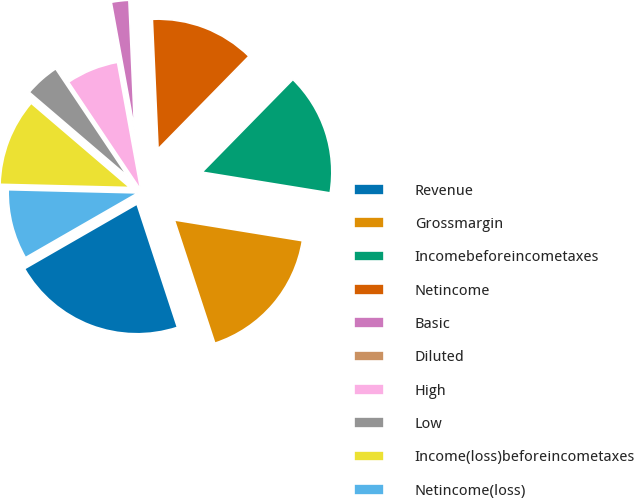<chart> <loc_0><loc_0><loc_500><loc_500><pie_chart><fcel>Revenue<fcel>Grossmargin<fcel>Incomebeforeincometaxes<fcel>Netincome<fcel>Basic<fcel>Diluted<fcel>High<fcel>Low<fcel>Income(loss)beforeincometaxes<fcel>Netincome(loss)<nl><fcel>21.74%<fcel>17.39%<fcel>15.22%<fcel>13.04%<fcel>2.17%<fcel>0.0%<fcel>6.52%<fcel>4.35%<fcel>10.87%<fcel>8.7%<nl></chart> 